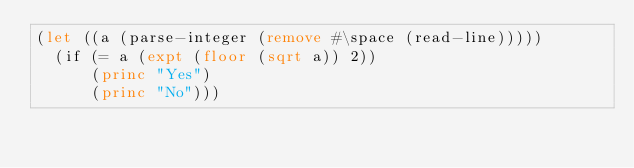<code> <loc_0><loc_0><loc_500><loc_500><_Lisp_>(let ((a (parse-integer (remove #\space (read-line)))))
  (if (= a (expt (floor (sqrt a)) 2))
      (princ "Yes")
      (princ "No")))
</code> 